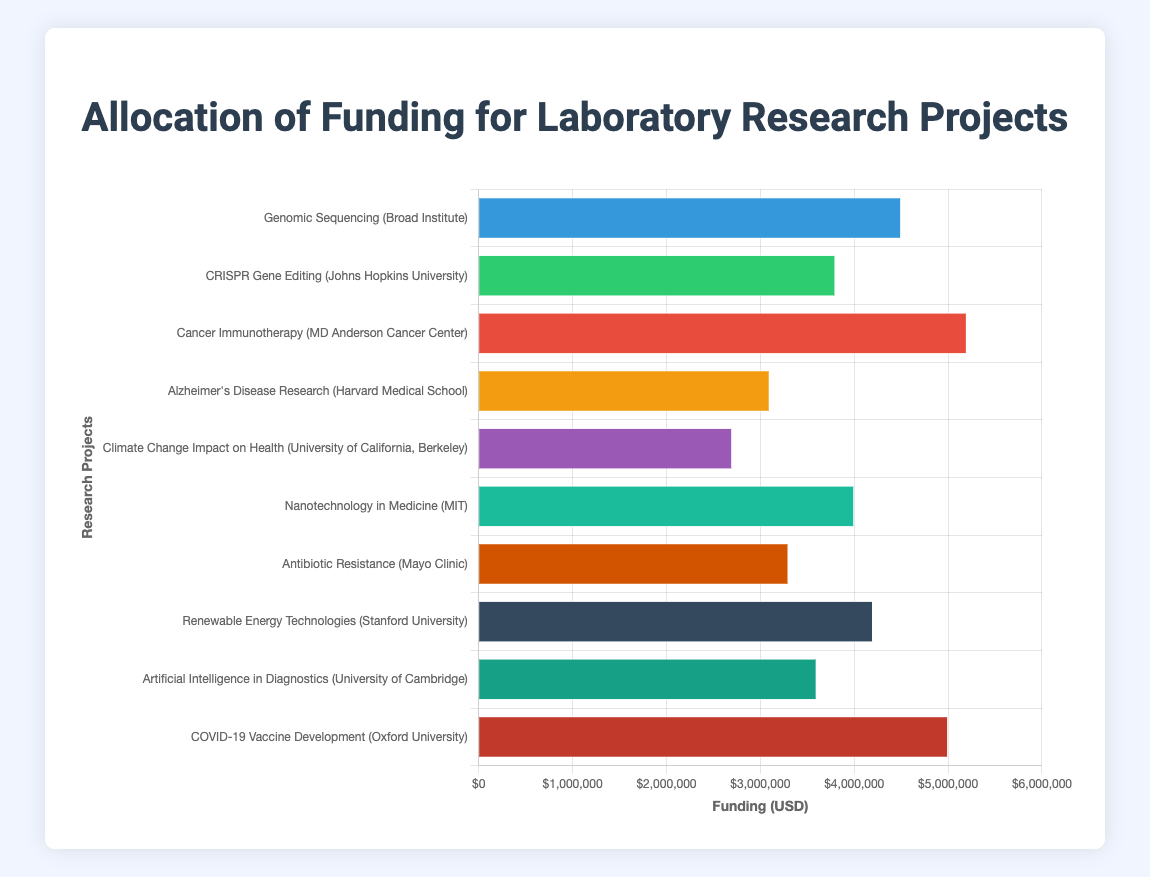Which project received the highest funding? The "Cancer Immunotherapy" project at MD Anderson Cancer Center received the highest funding, which can be determined by visually comparing the lengths of the bars in the chart. The bar representing Cancer Immunotherapy is the longest.
Answer: Cancer Immunotherapy Which two projects received a total funding amounting to exactly $8,000,000 when combined? Adding the funding for "CRISPR Gene Editing" ($3,800,000) and "Renewable Energy Technologies" ($4,200,000) results in exactly $8,000,000.
Answer: CRISPR Gene Editing and Renewable Energy Technologies Which project received the least funding, and what is that amount? The "Climate Change Impact on Health" project at University of California, Berkeley received the least funding. This can be seen by identifying the shortest bar in the chart.
Answer: Climate Change Impact on Health, $2,700,000 How much more funding did the COVID-19 Vaccine Development project receive compared to the Alzheimer's Disease Research project? The difference can be found by subtracting the funding for Alzheimer's Disease Research ($3,100,000) from the funding for COVID-19 Vaccine Development ($5,000,000). The calculation is $5,000,000 - $3,100,000 = $1,900,000.
Answer: $1,900,000 What is the total funding allocated to artificial intelligence-related projects? The only project directly related to artificial intelligence is "Artificial Intelligence in Diagnostics", which received funding of $3,600,000. The calculation is $3,600,000.
Answer: $3,600,000 Which projects received $4,000,000 or more in funding? The projects that received $4,000,000 or more are "Genomic Sequencing", "Cancer Immunotherapy", "Nanotechnology in Medicine", "Renewable Energy Technologies", and "COVID-19 Vaccine Development". This is determined by identifying the bars that extend beyond the $4,000,000 mark.
Answer: Genomic Sequencing, Cancer Immunotherapy, Nanotechnology in Medicine, Renewable Energy Technologies, COVID-19 Vaccine Development What is the average funding amount for all listed projects? Adding the total funding for all projects ($45,700,000) and dividing by the number of projects (10) gives the average. The calculation is $45,700,000 / 10 = $4,570,000.
Answer: $4,570,000 Which institution received the highest cumulative funding for its projects? Summing the funding for each institution's projects and comparing totals, Oxford University with $5,000,000 for one project, MD Anderson Cancer Center with $5,200,000 for one project, and Broad Institute with $4,500,000 for one project. MD Anderson Cancer Center received the highest cumulative funding.
Answer: MD Anderson Cancer Center 